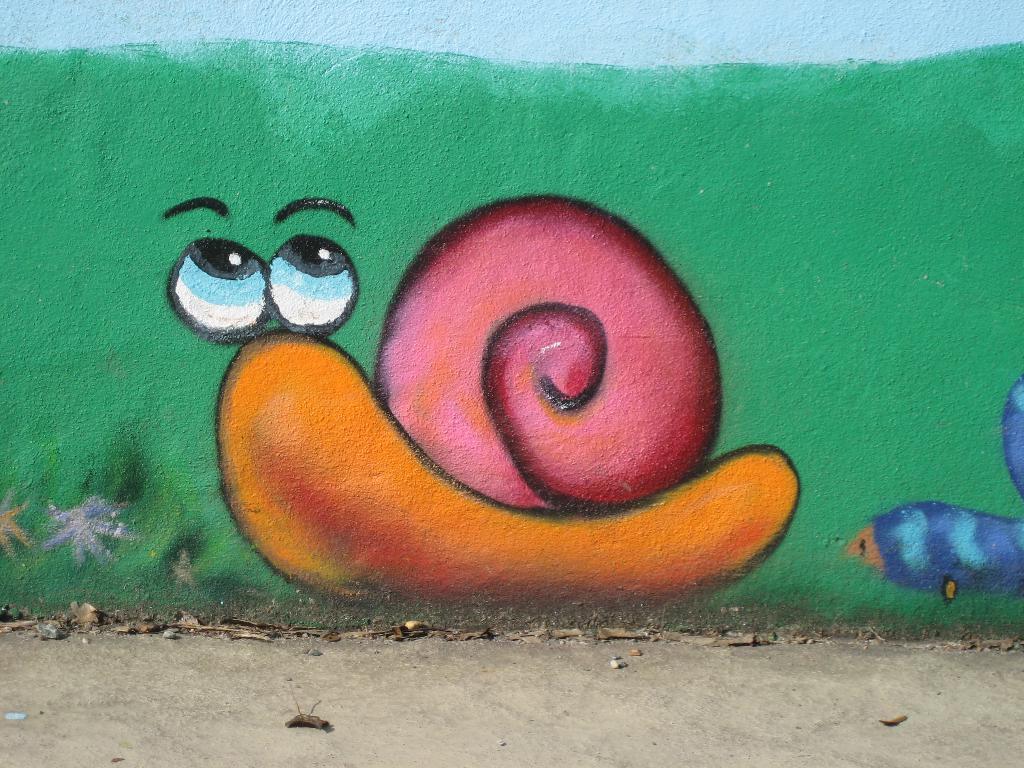How would you summarize this image in a sentence or two? In this image we can see painting of a snail on the wall. 